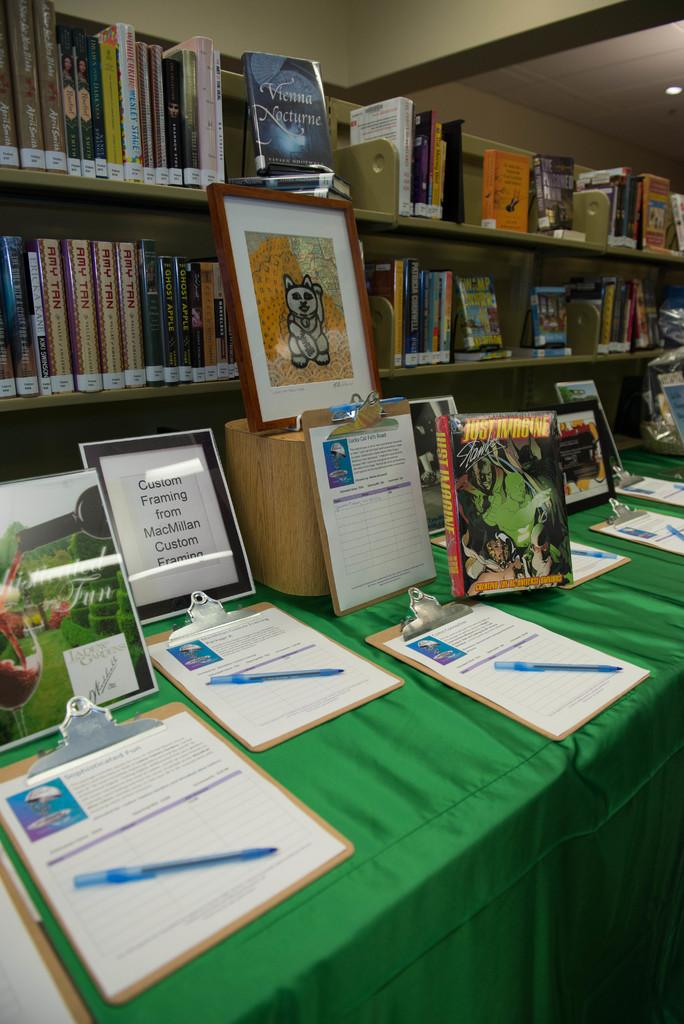Provide a one-sentence caption for the provided image. One of the books on display on the table is titled Just Imagine. 